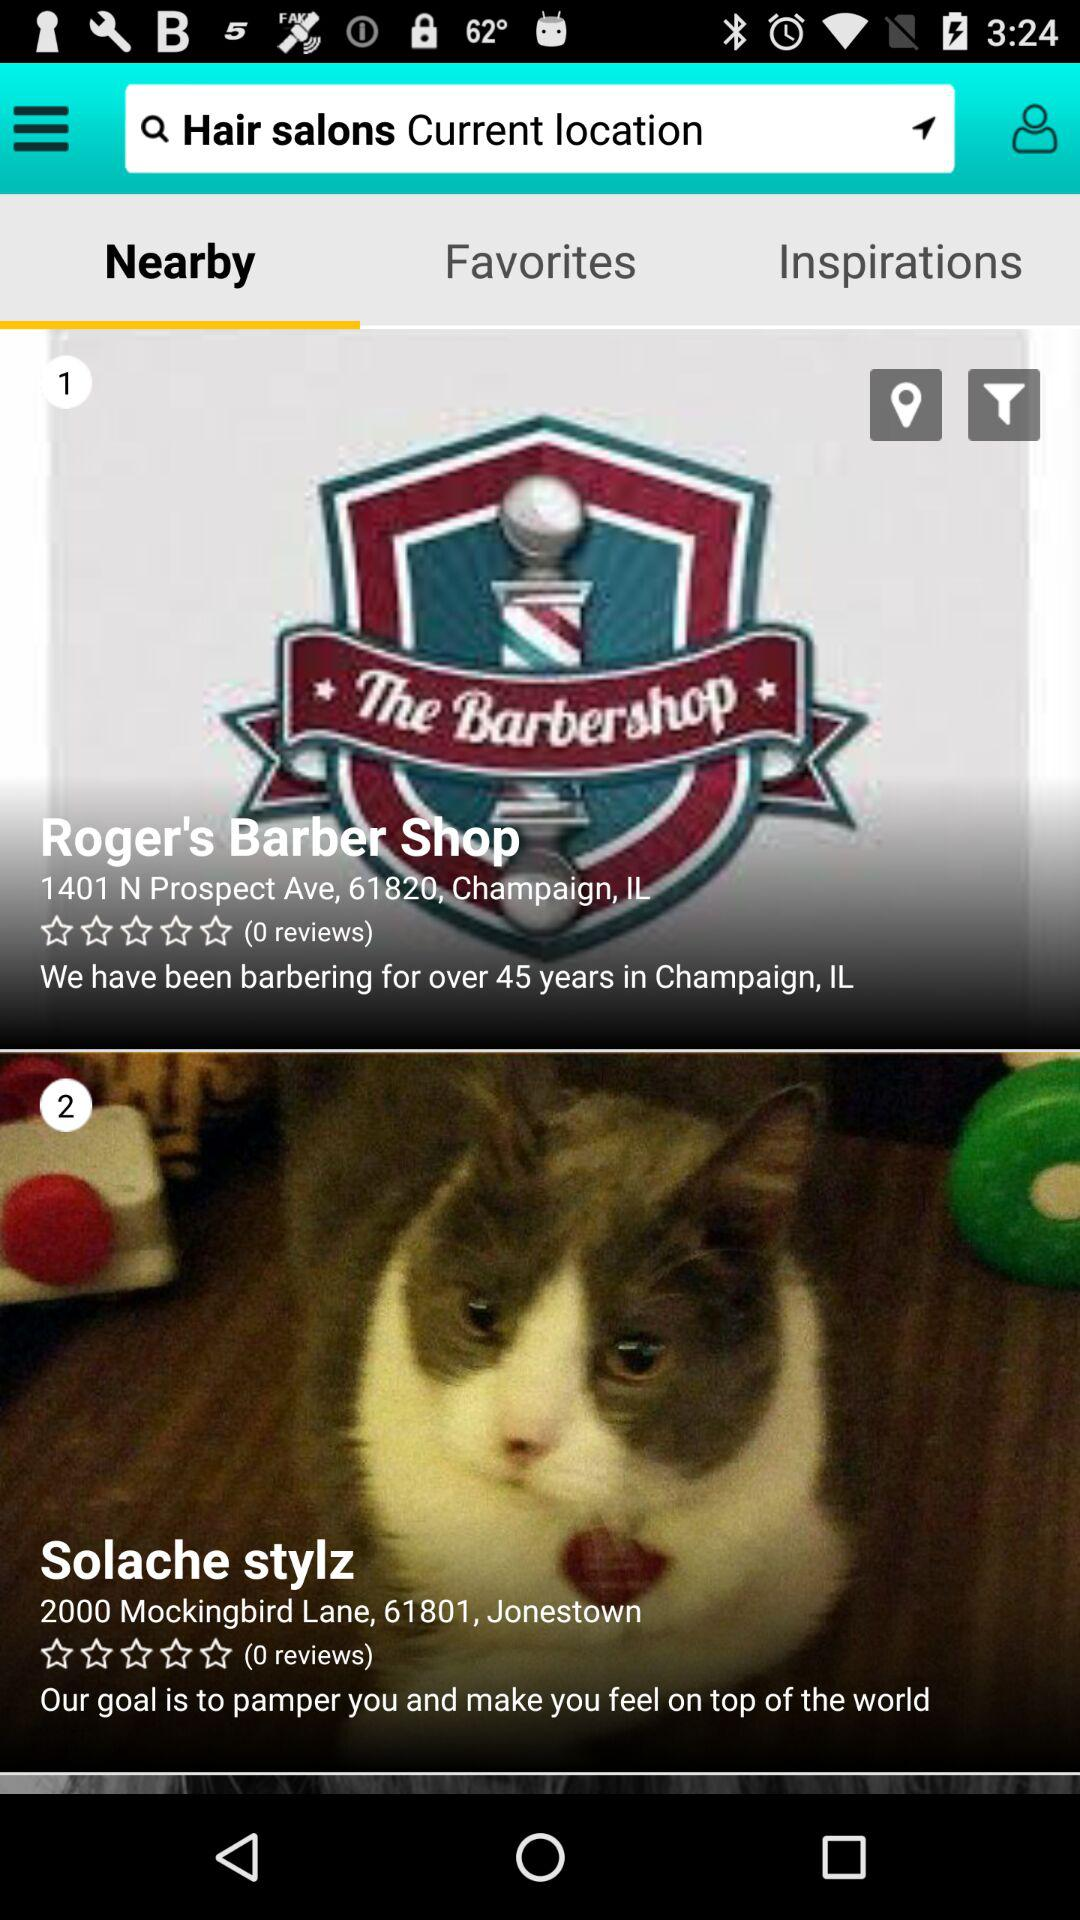What is the location of Roger's Barber Shop? The location is 1401 N Prospect Ave, 61820, Champaign, IL. 